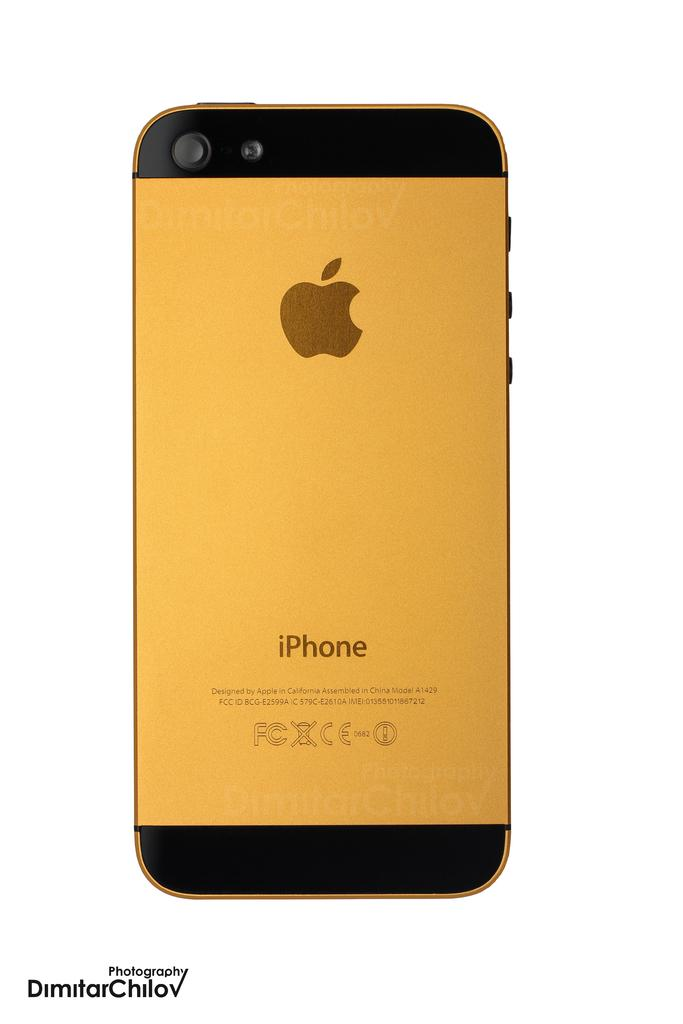<image>
Describe the image concisely. the back side of a gold iPHONE taken by Dimitar Chilov 